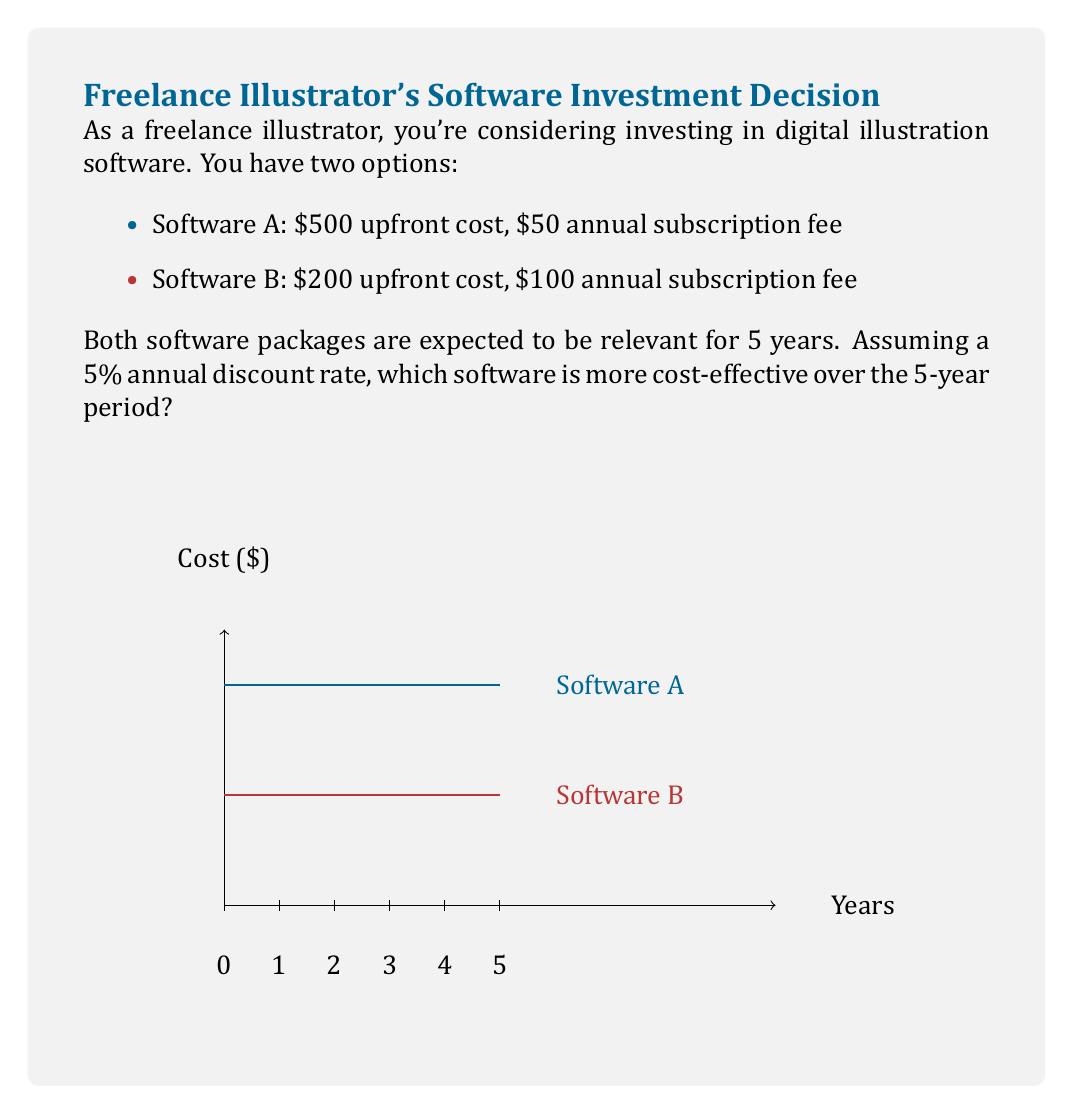What is the answer to this math problem? To determine which software is more cost-effective, we need to calculate the Net Present Value (NPV) of each option over 5 years.

1. Calculate the present value of annual fees:
   Let $r$ be the discount rate (5% = 0.05)
   Present Value of Annuity = Annual Fee * $\frac{1-(1+r)^{-n}}{r}$

   For Software A: $50 * \frac{1-(1+0.05)^{-5}}{0.05} = 216.47$
   For Software B: $100 * \frac{1-(1+0.05)^{-5}}{0.05} = 432.95$

2. Calculate total NPV for each software:
   NPV = Upfront Cost + Present Value of Annuity

   Software A: $500 + 216.47 = 716.47$
   Software B: $200 + 432.95 = 632.95$

3. Compare the NPVs:
   Software B has a lower NPV ($632.95 < $716.47)

Therefore, Software B is more cost-effective over the 5-year period.
Answer: Software B ($632.95 NPV) 